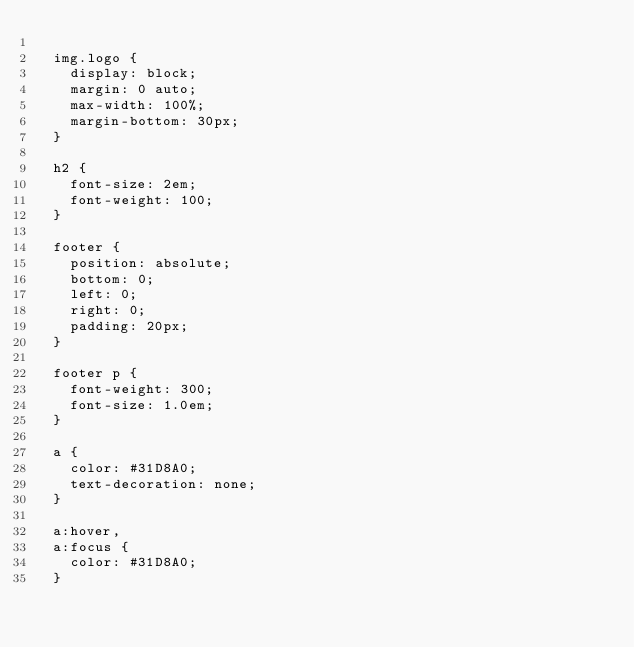Convert code to text. <code><loc_0><loc_0><loc_500><loc_500><_CSS_>
	img.logo {
	  display: block;
	  margin: 0 auto;
	  max-width: 100%;
	  margin-bottom: 30px;
	}

	h2 {
	  font-size: 2em;
	  font-weight: 100;
	}

	footer {
	  position: absolute;
	  bottom: 0;
	  left: 0;
	  right: 0;
	  padding: 20px;
	}

	footer p {
	  font-weight: 300;
	  font-size: 1.0em;
	}

	a {
	  color: #31D8A0;
	  text-decoration: none;
	}

	a:hover,
	a:focus {
	  color: #31D8A0;
	}</code> 